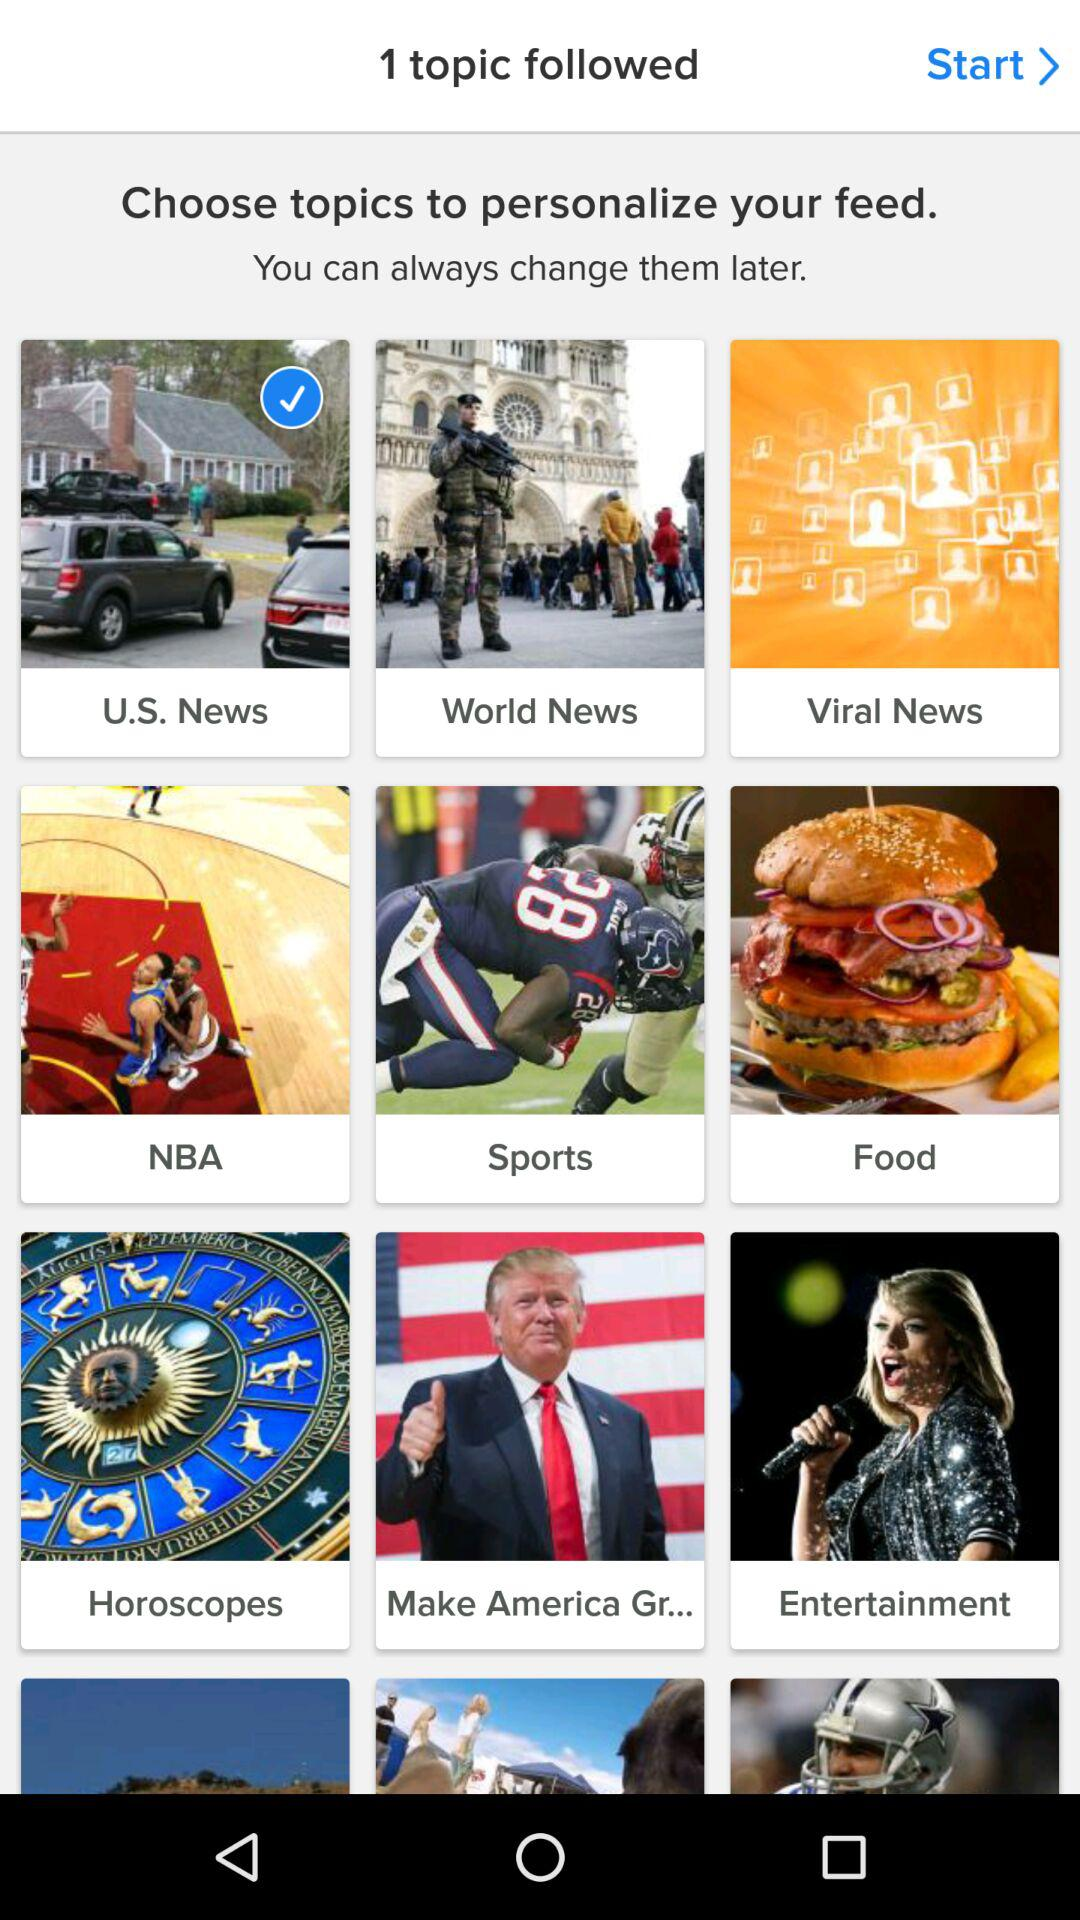How many topics are followed? There is only 1 topic followed. 